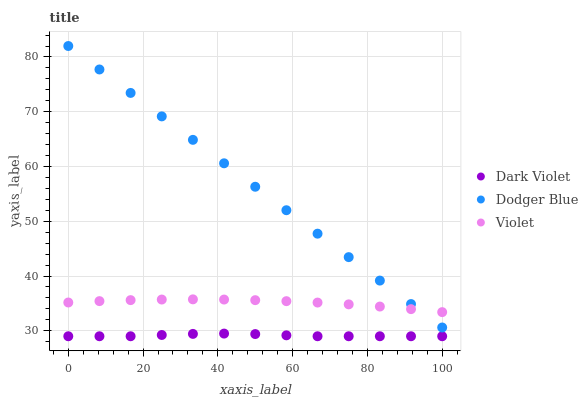Does Dark Violet have the minimum area under the curve?
Answer yes or no. Yes. Does Dodger Blue have the maximum area under the curve?
Answer yes or no. Yes. Does Violet have the minimum area under the curve?
Answer yes or no. No. Does Violet have the maximum area under the curve?
Answer yes or no. No. Is Dodger Blue the smoothest?
Answer yes or no. Yes. Is Dark Violet the roughest?
Answer yes or no. Yes. Is Violet the smoothest?
Answer yes or no. No. Is Violet the roughest?
Answer yes or no. No. Does Dark Violet have the lowest value?
Answer yes or no. Yes. Does Violet have the lowest value?
Answer yes or no. No. Does Dodger Blue have the highest value?
Answer yes or no. Yes. Does Violet have the highest value?
Answer yes or no. No. Is Dark Violet less than Dodger Blue?
Answer yes or no. Yes. Is Dodger Blue greater than Dark Violet?
Answer yes or no. Yes. Does Violet intersect Dodger Blue?
Answer yes or no. Yes. Is Violet less than Dodger Blue?
Answer yes or no. No. Is Violet greater than Dodger Blue?
Answer yes or no. No. Does Dark Violet intersect Dodger Blue?
Answer yes or no. No. 